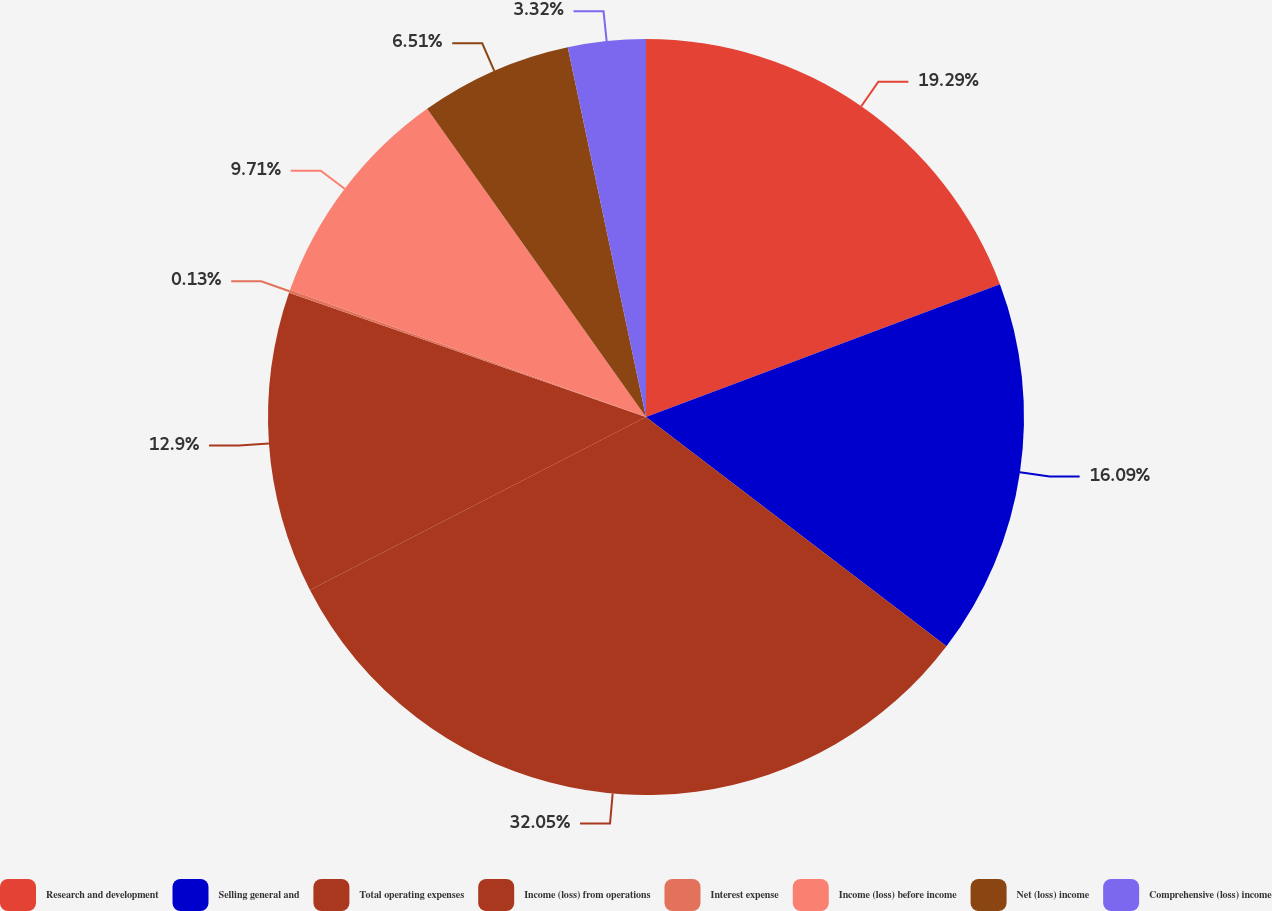Convert chart to OTSL. <chart><loc_0><loc_0><loc_500><loc_500><pie_chart><fcel>Research and development<fcel>Selling general and<fcel>Total operating expenses<fcel>Income (loss) from operations<fcel>Interest expense<fcel>Income (loss) before income<fcel>Net (loss) income<fcel>Comprehensive (loss) income<nl><fcel>19.29%<fcel>16.09%<fcel>32.06%<fcel>12.9%<fcel>0.13%<fcel>9.71%<fcel>6.51%<fcel>3.32%<nl></chart> 